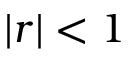<formula> <loc_0><loc_0><loc_500><loc_500>| r | < 1</formula> 